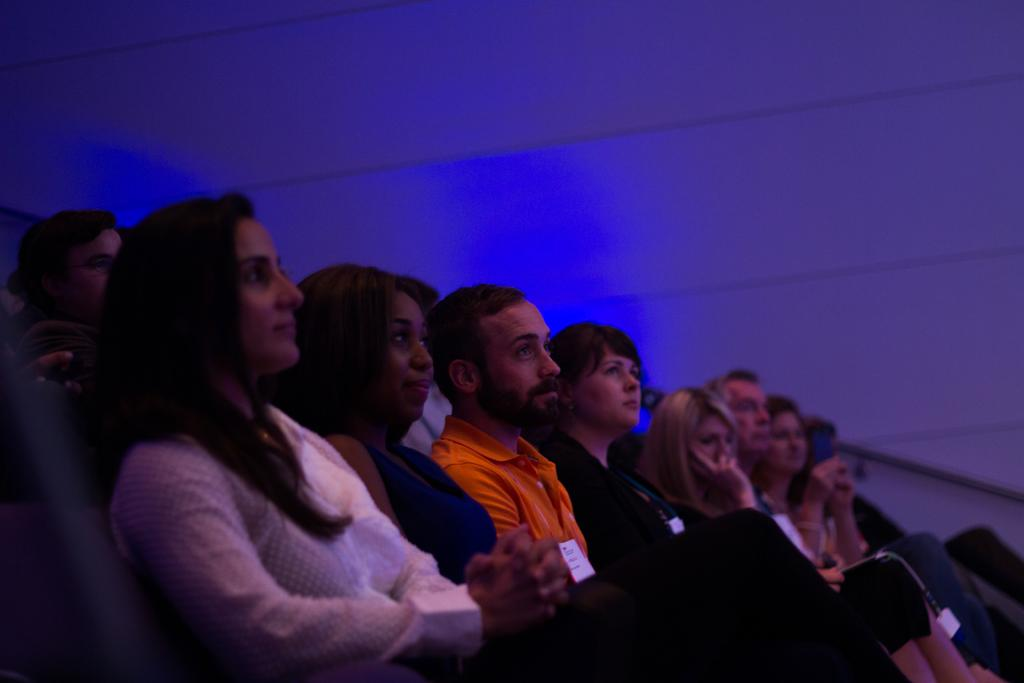What are the people in the image doing? There are people sitting in the image. What can be seen in the background of the image? There is a wall and a rod in the background of the image. What type of brass instrument is being played by the people in the image? There is no brass instrument present in the image; the people are simply sitting. What flavor of cake is being served to the people in the image? There is no cake present in the image. 